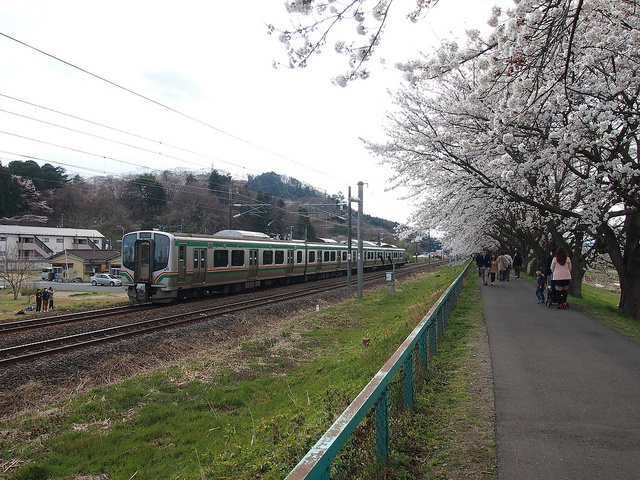Describe the objects in this image and their specific colors. I can see train in white, black, gray, darkgray, and teal tones, people in white, black, gray, and maroon tones, car in white, gray, darkgray, black, and lightgray tones, people in white, black, gray, and blue tones, and people in white, black, gray, maroon, and blue tones in this image. 